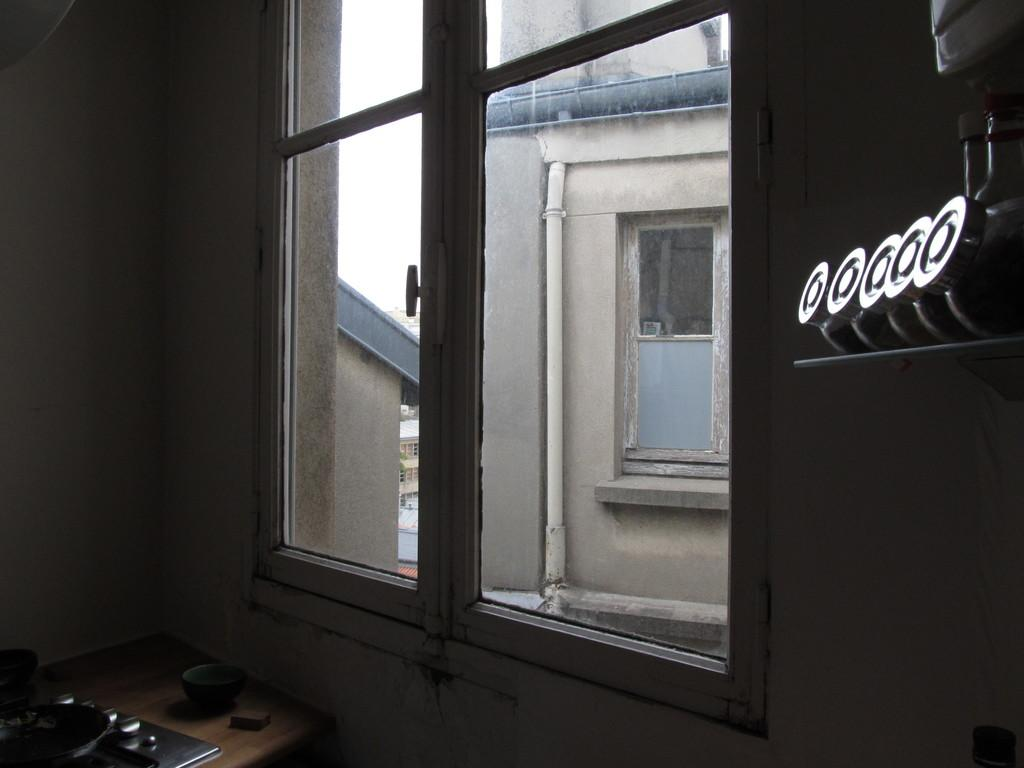What is the person in the image holding? The person is holding a book. Are there any other books visible in the image? Yes, there are books on a table. What might be the purpose of the books in the image? The books could be for reading or studying. How does the coach help the person in the image? There is no coach present in the image. What is the servant doing in the image? There is no servant present in the image. 